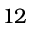<formula> <loc_0><loc_0><loc_500><loc_500>1 2</formula> 